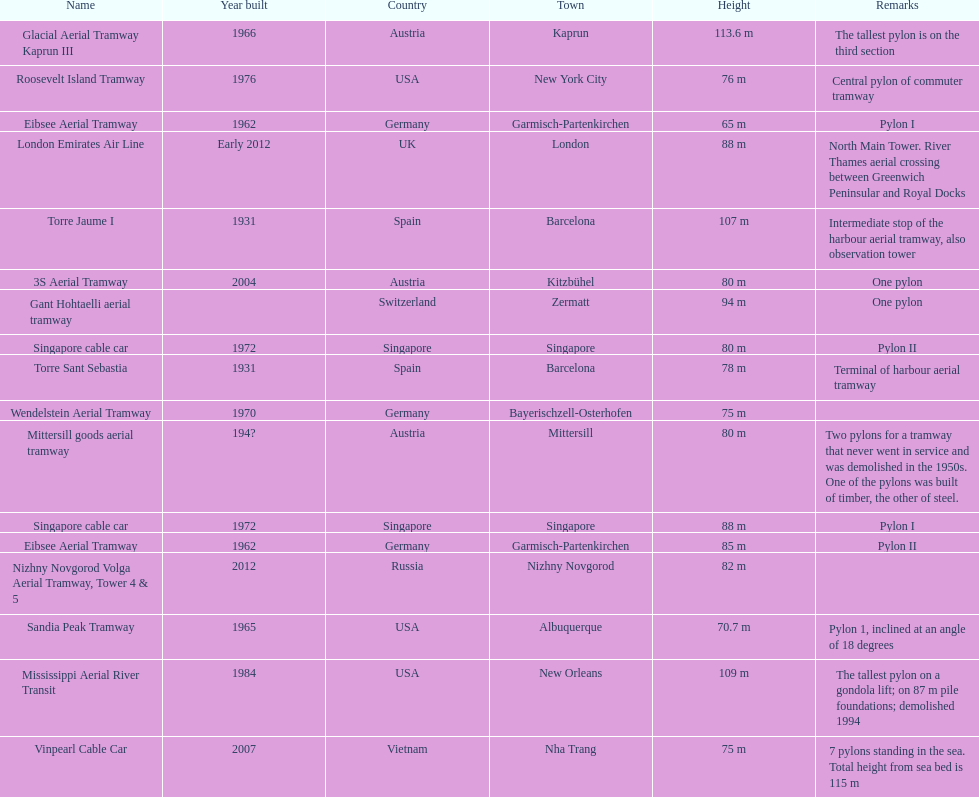List two pylons that are at most, 80 m in height. Mittersill goods aerial tramway, Singapore cable car. 